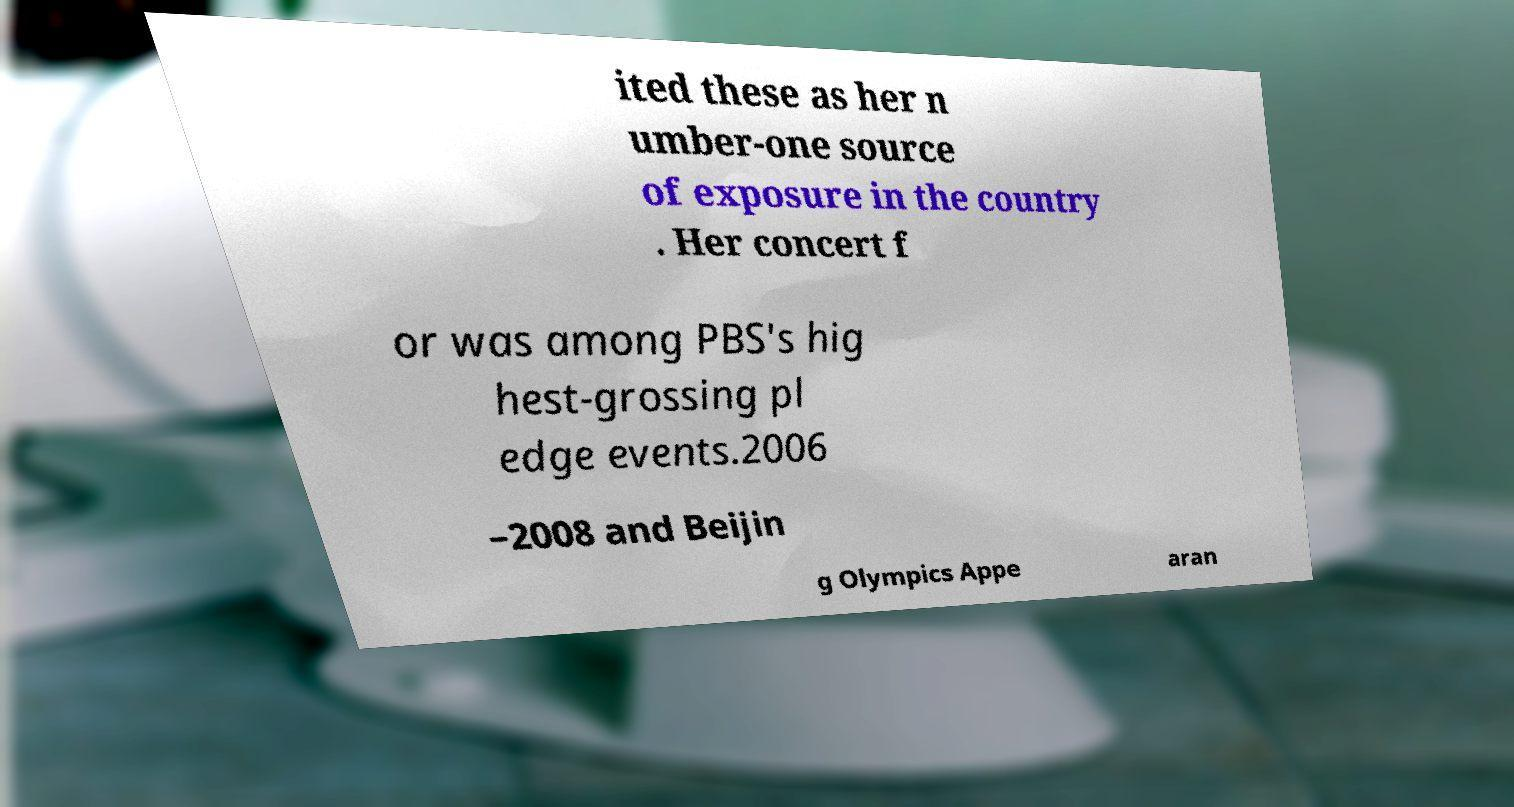Could you extract and type out the text from this image? ited these as her n umber-one source of exposure in the country . Her concert f or was among PBS's hig hest-grossing pl edge events.2006 –2008 and Beijin g Olympics Appe aran 